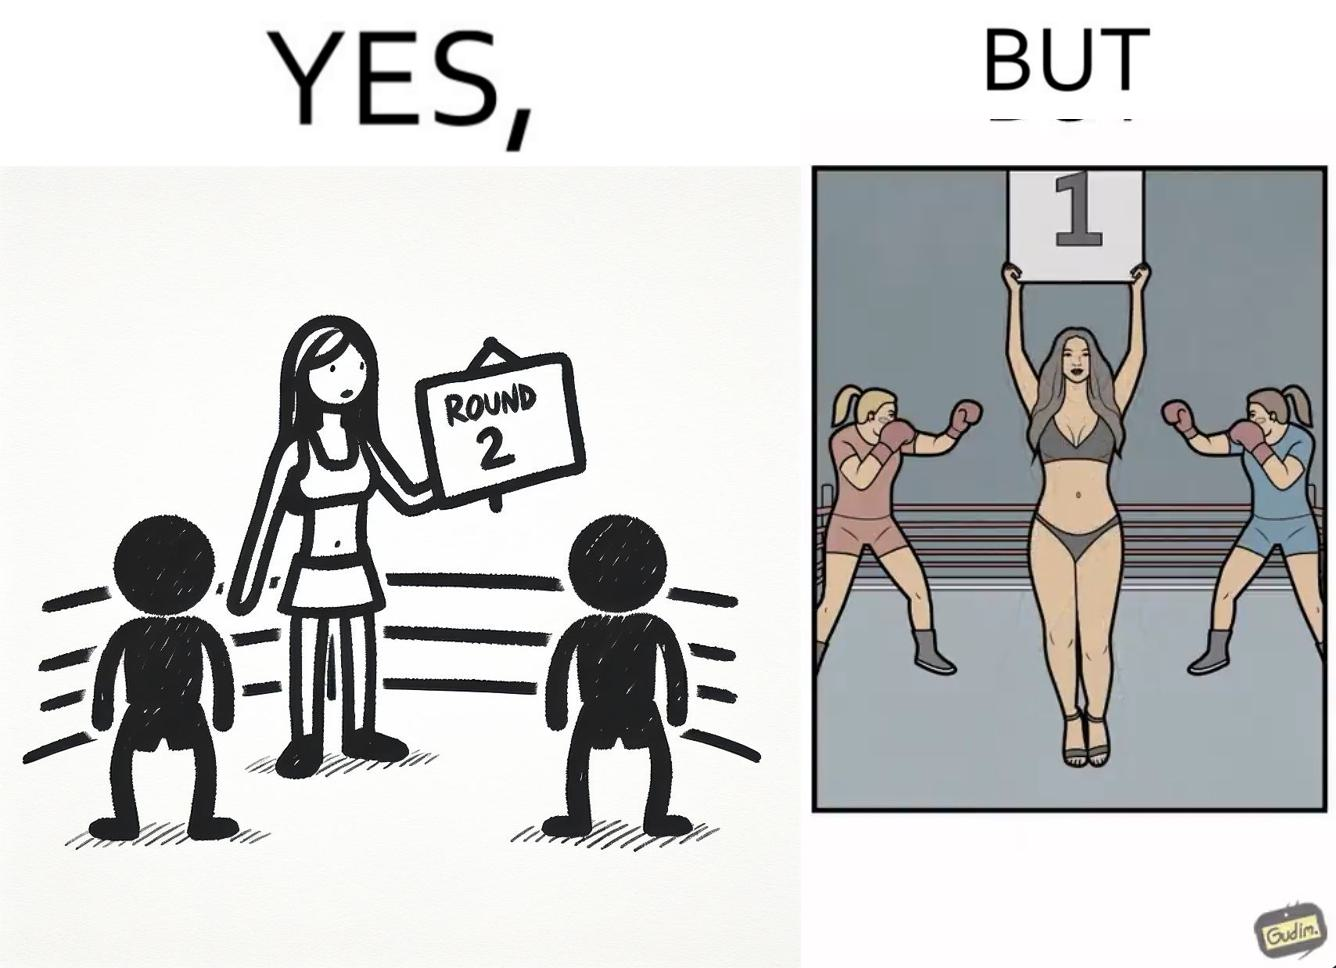What is shown in this image? This is a satirical image with contrasting elements. 